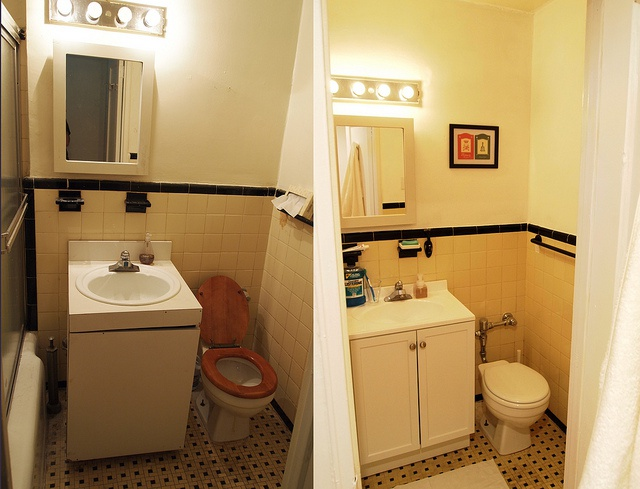Describe the objects in this image and their specific colors. I can see sink in black, tan, and gray tones, toilet in black, maroon, and gray tones, toilet in black, olive, tan, and maroon tones, sink in black, khaki, and tan tones, and bottle in black, olive, gray, and maroon tones in this image. 